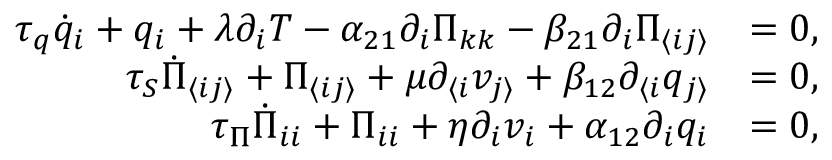Convert formula to latex. <formula><loc_0><loc_0><loc_500><loc_500>\begin{array} { r l } { \tau _ { q } \dot { q } _ { i } + q _ { i } + \lambda \partial _ { i } T - \alpha _ { 2 1 } \partial _ { i } \Pi _ { k k } - \beta _ { 2 1 } \partial _ { i } \Pi _ { \langle i j \rangle } } & { = 0 , } \\ { \tau _ { S } \dot { \Pi } _ { \langle i j \rangle } + \Pi _ { \langle i j \rangle } + \mu \partial _ { \langle i } v _ { j \rangle } + \beta _ { 1 2 } \partial _ { \langle i } q _ { j \rangle } } & { = 0 , } \\ { \tau _ { \Pi } \dot { \Pi } _ { i i } + \Pi _ { i i } + \eta \partial _ { i } v _ { i } + \alpha _ { 1 2 } \partial _ { i } q _ { i } } & { = 0 , } \end{array}</formula> 